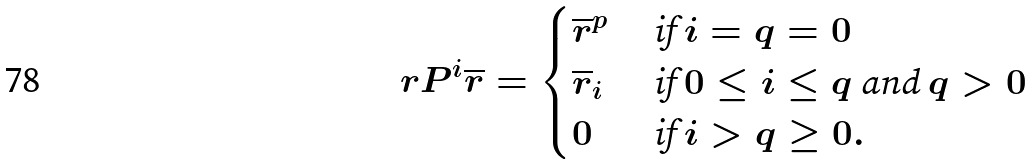<formula> <loc_0><loc_0><loc_500><loc_500>\ r P ^ { i } \overline { r } = \begin{cases} \overline { r } ^ { p } & \text { if } i = q = 0 \\ \overline { r } _ { i } & \text { if } 0 \leq i \leq q \text { and } q > 0 \\ 0 & \text { if } i > q \geq 0 . \end{cases}</formula> 